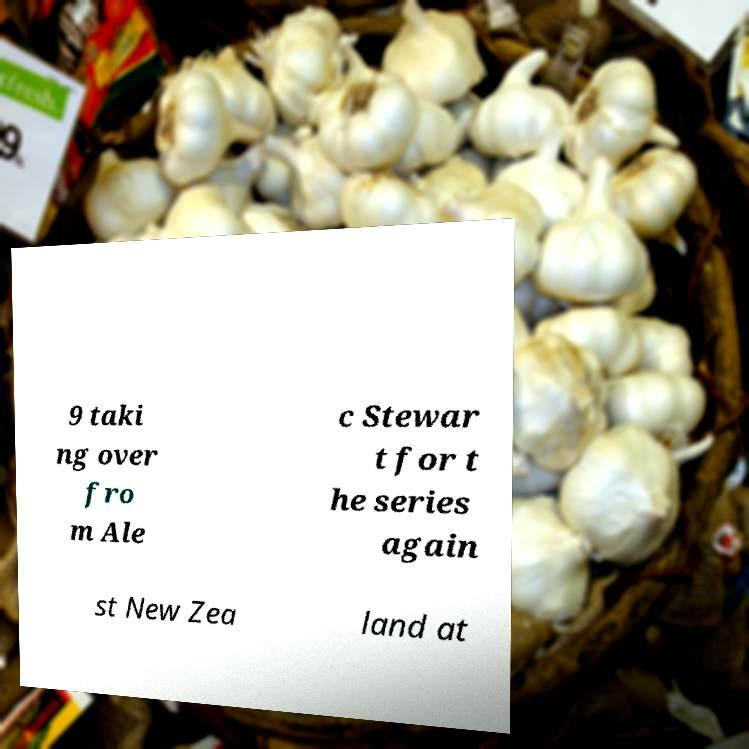Could you assist in decoding the text presented in this image and type it out clearly? 9 taki ng over fro m Ale c Stewar t for t he series again st New Zea land at 